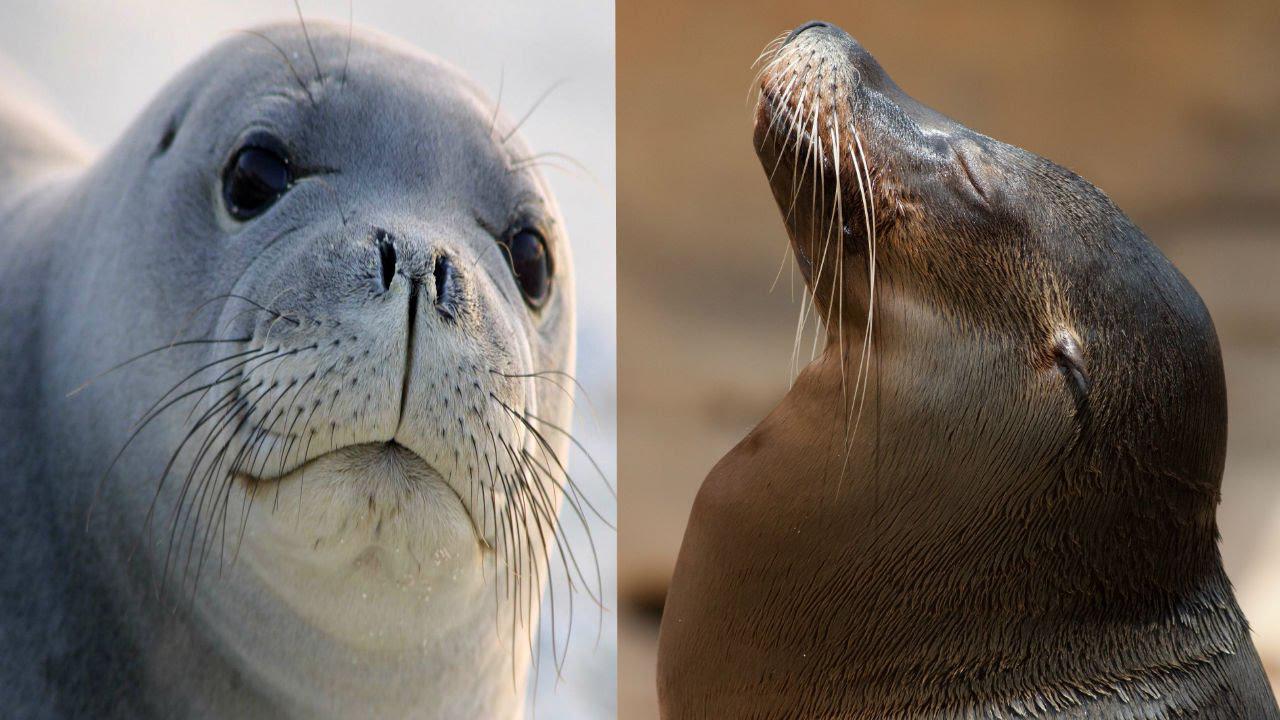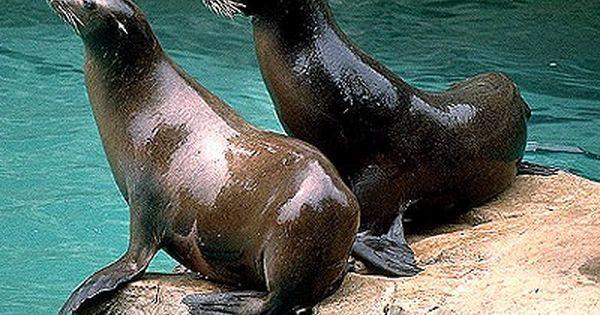The first image is the image on the left, the second image is the image on the right. For the images shown, is this caption "In the right image there is a single seal looking at the camera." true? Answer yes or no. No. The first image is the image on the left, the second image is the image on the right. For the images displayed, is the sentence "One image shows a seal lying on its side on a flat, unelevated surface with its head raised and turned to the camera." factually correct? Answer yes or no. No. 